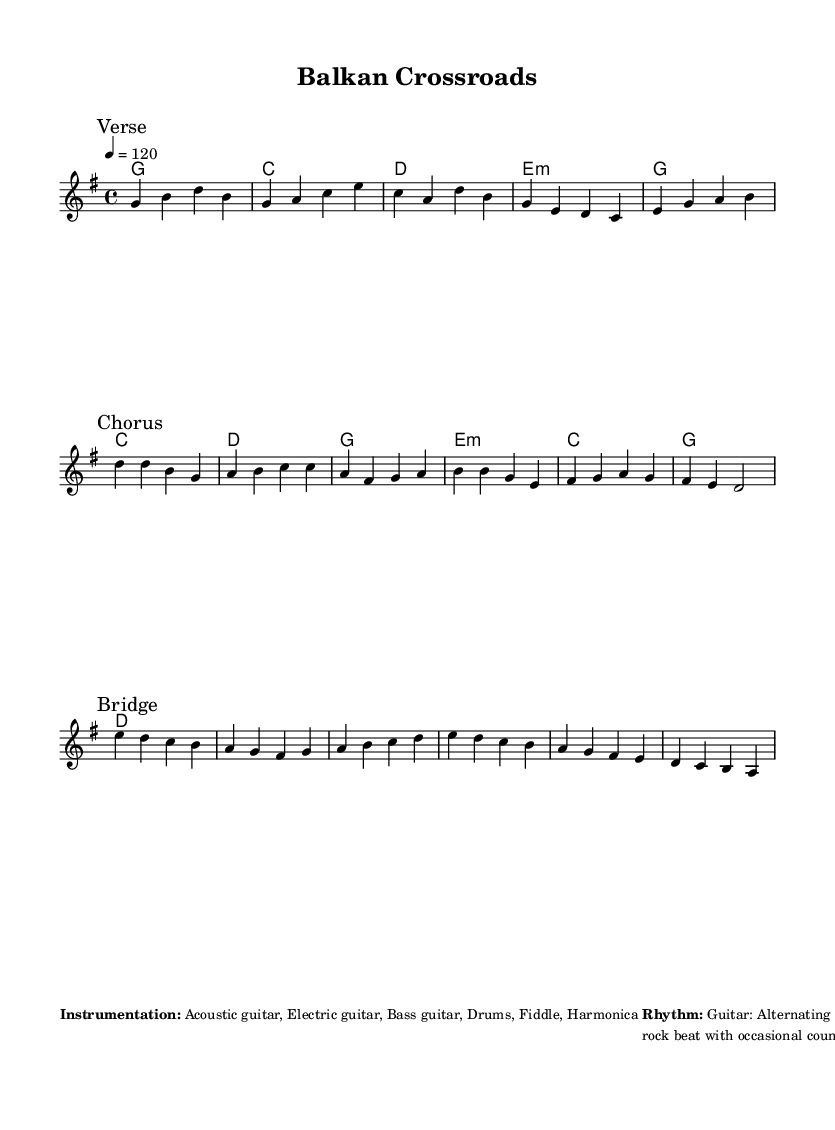What is the key signature of this music? The key signature is G major, indicated by one sharp, which is F#. The melody and harmonies confirm this since they include notes consistent with the G major scale.
Answer: G major What is the time signature of this music? The time signature is 4/4, which is indicated at the beginning of the score. This means there are four beats in each measure.
Answer: 4/4 What is the tempo marking for this piece? The tempo marking is "4 = 120", meaning that quarter notes are to be played at a speed of 120 beats per minute. This is a relatively fast tempo for a country-rock song.
Answer: 120 How many sections are in the song? The song consists of three sections as labeled: Verse, Chorus, and Bridge, indicating a standard song structure.
Answer: Three What instrumentation is used in this piece? The instrumentation listed includes Acoustic guitar, Electric guitar, Bass guitar, Drums, Fiddle, and Harmonica, which are typical for country-rock fusion to create a rich sound.
Answer: Acoustic guitar, Electric guitar, Bass guitar, Drums, Fiddle, Harmonica What type of rhythm is the guitar part playing? The guitar is alternating between country-style fingerpicking and rock power chords, creating a fusion sound characteristic of the genre.
Answer: Alternating between country-style fingerpicking and rock power chords What unique element is incorporated into the bridge? Traditional Serbian folk elements are incorporated during the bridge, showcasing a fusion of cultural influences within the music.
Answer: Traditional Serbian folk elements 